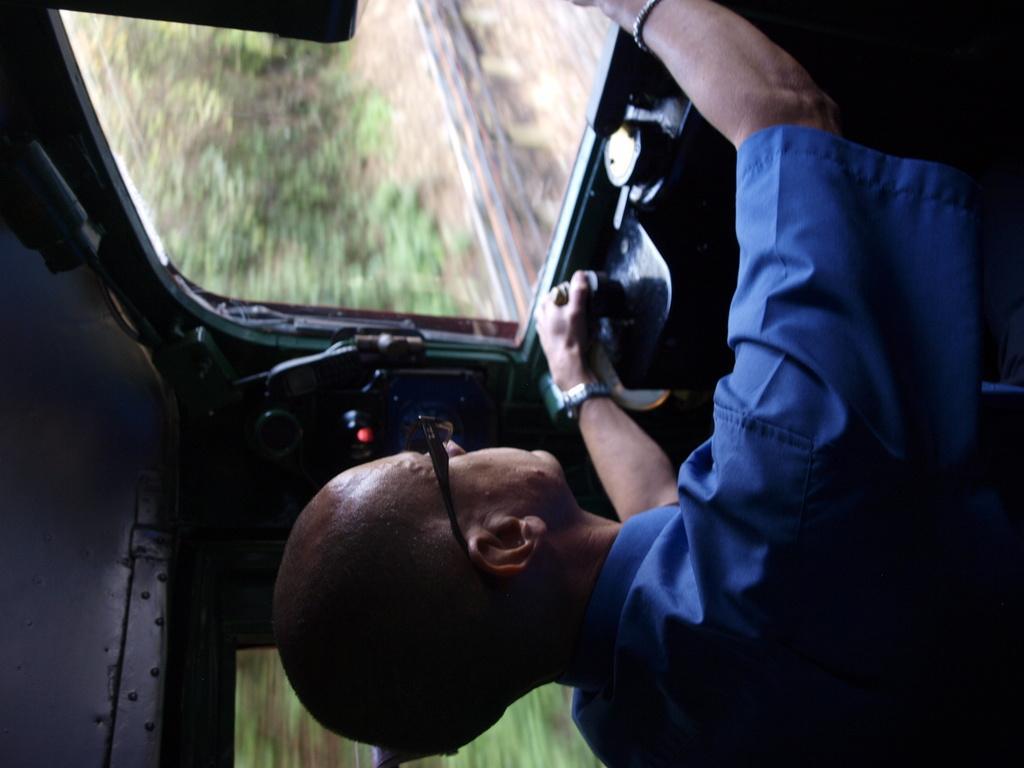Could you give a brief overview of what you see in this image? This picture is taken inside a vehicle. A person wearing a blue shirt is sitting inside a vehicle and driving. Behind the vehicle there are few trees are on the land. 